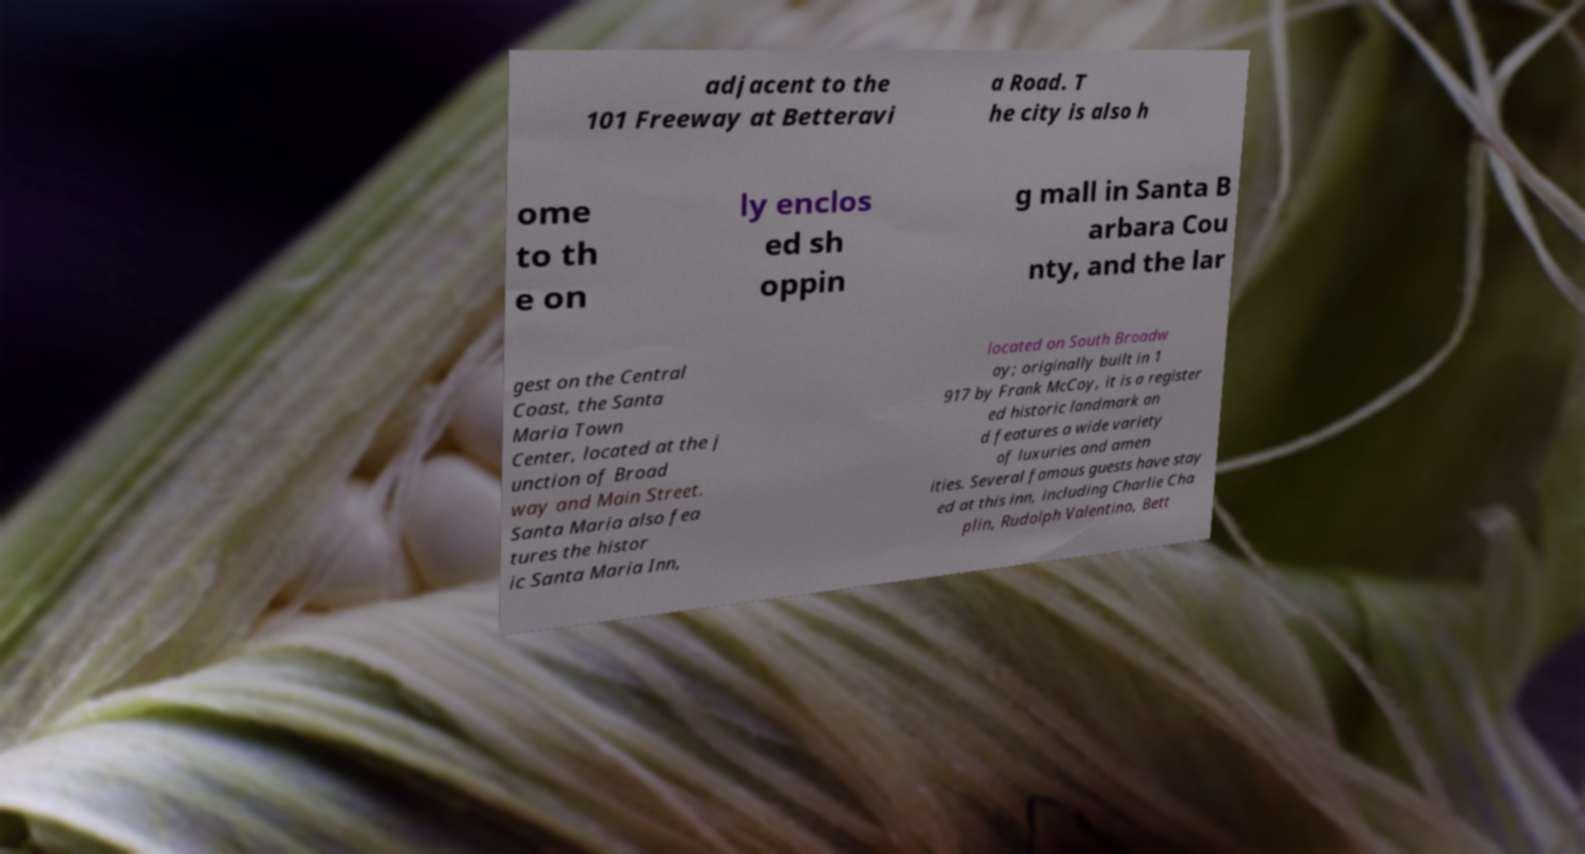I need the written content from this picture converted into text. Can you do that? adjacent to the 101 Freeway at Betteravi a Road. T he city is also h ome to th e on ly enclos ed sh oppin g mall in Santa B arbara Cou nty, and the lar gest on the Central Coast, the Santa Maria Town Center, located at the j unction of Broad way and Main Street. Santa Maria also fea tures the histor ic Santa Maria Inn, located on South Broadw ay; originally built in 1 917 by Frank McCoy, it is a register ed historic landmark an d features a wide variety of luxuries and amen ities. Several famous guests have stay ed at this inn, including Charlie Cha plin, Rudolph Valentino, Bett 